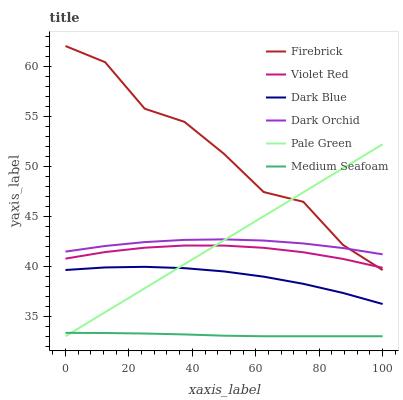Does Medium Seafoam have the minimum area under the curve?
Answer yes or no. Yes. Does Firebrick have the maximum area under the curve?
Answer yes or no. Yes. Does Dark Orchid have the minimum area under the curve?
Answer yes or no. No. Does Dark Orchid have the maximum area under the curve?
Answer yes or no. No. Is Pale Green the smoothest?
Answer yes or no. Yes. Is Firebrick the roughest?
Answer yes or no. Yes. Is Dark Orchid the smoothest?
Answer yes or no. No. Is Dark Orchid the roughest?
Answer yes or no. No. Does Pale Green have the lowest value?
Answer yes or no. Yes. Does Firebrick have the lowest value?
Answer yes or no. No. Does Firebrick have the highest value?
Answer yes or no. Yes. Does Dark Orchid have the highest value?
Answer yes or no. No. Is Medium Seafoam less than Dark Orchid?
Answer yes or no. Yes. Is Dark Orchid greater than Violet Red?
Answer yes or no. Yes. Does Firebrick intersect Pale Green?
Answer yes or no. Yes. Is Firebrick less than Pale Green?
Answer yes or no. No. Is Firebrick greater than Pale Green?
Answer yes or no. No. Does Medium Seafoam intersect Dark Orchid?
Answer yes or no. No. 